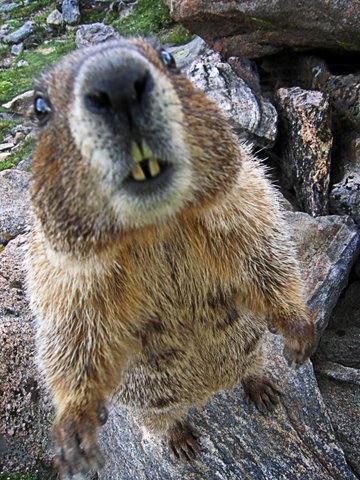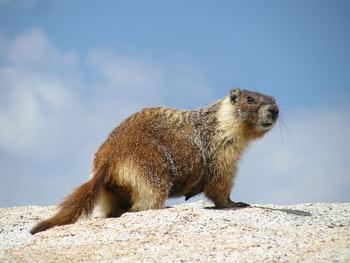The first image is the image on the left, the second image is the image on the right. Examine the images to the left and right. Is the description "An image shows only one marmot, which is on all fours with body and head facing right." accurate? Answer yes or no. Yes. 